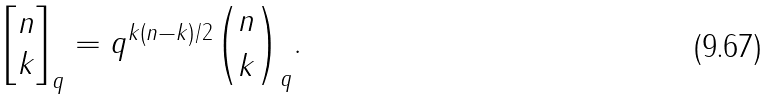Convert formula to latex. <formula><loc_0><loc_0><loc_500><loc_500>\left [ \begin{matrix} n \\ k \end{matrix} \right ] _ { q } = q ^ { k ( n - k ) / 2 } \binom { n } { k } _ { q } .</formula> 